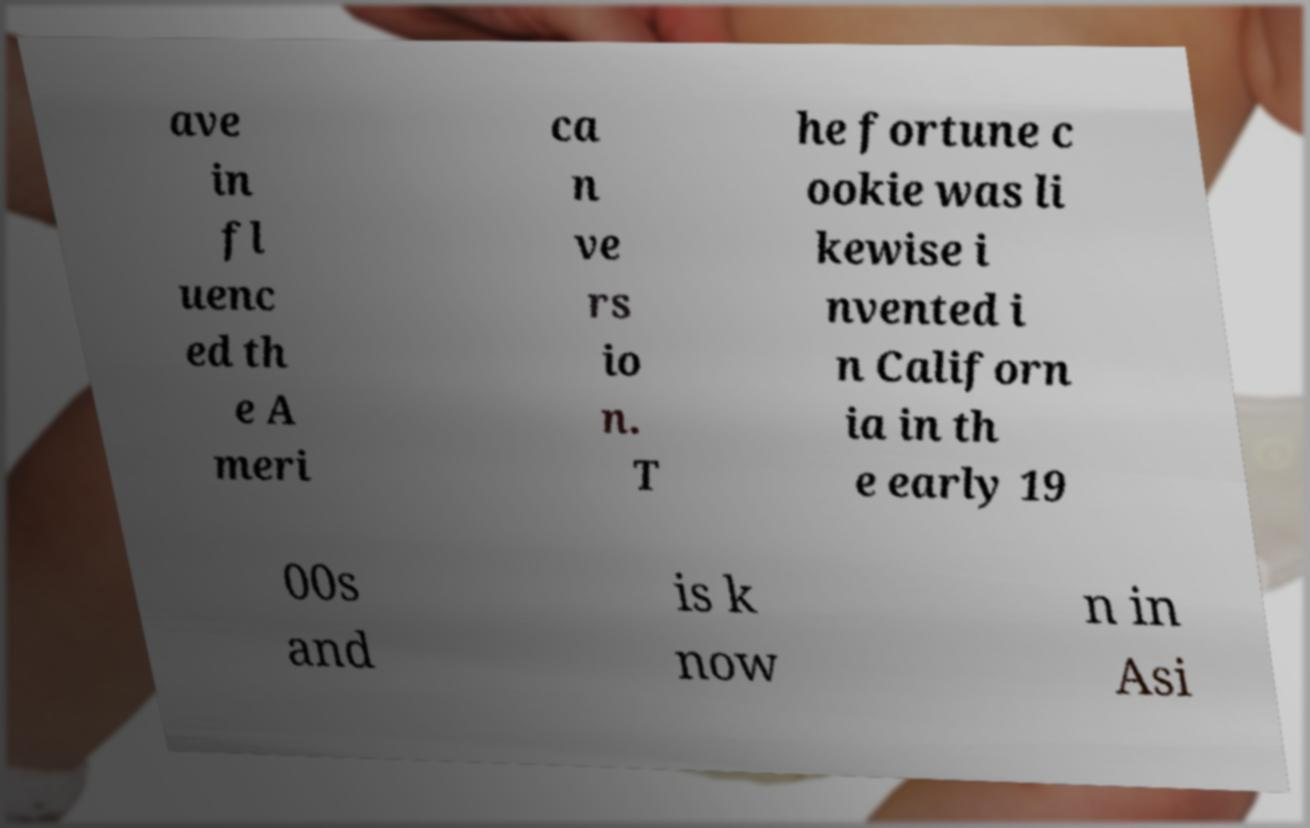There's text embedded in this image that I need extracted. Can you transcribe it verbatim? ave in fl uenc ed th e A meri ca n ve rs io n. T he fortune c ookie was li kewise i nvented i n Californ ia in th e early 19 00s and is k now n in Asi 